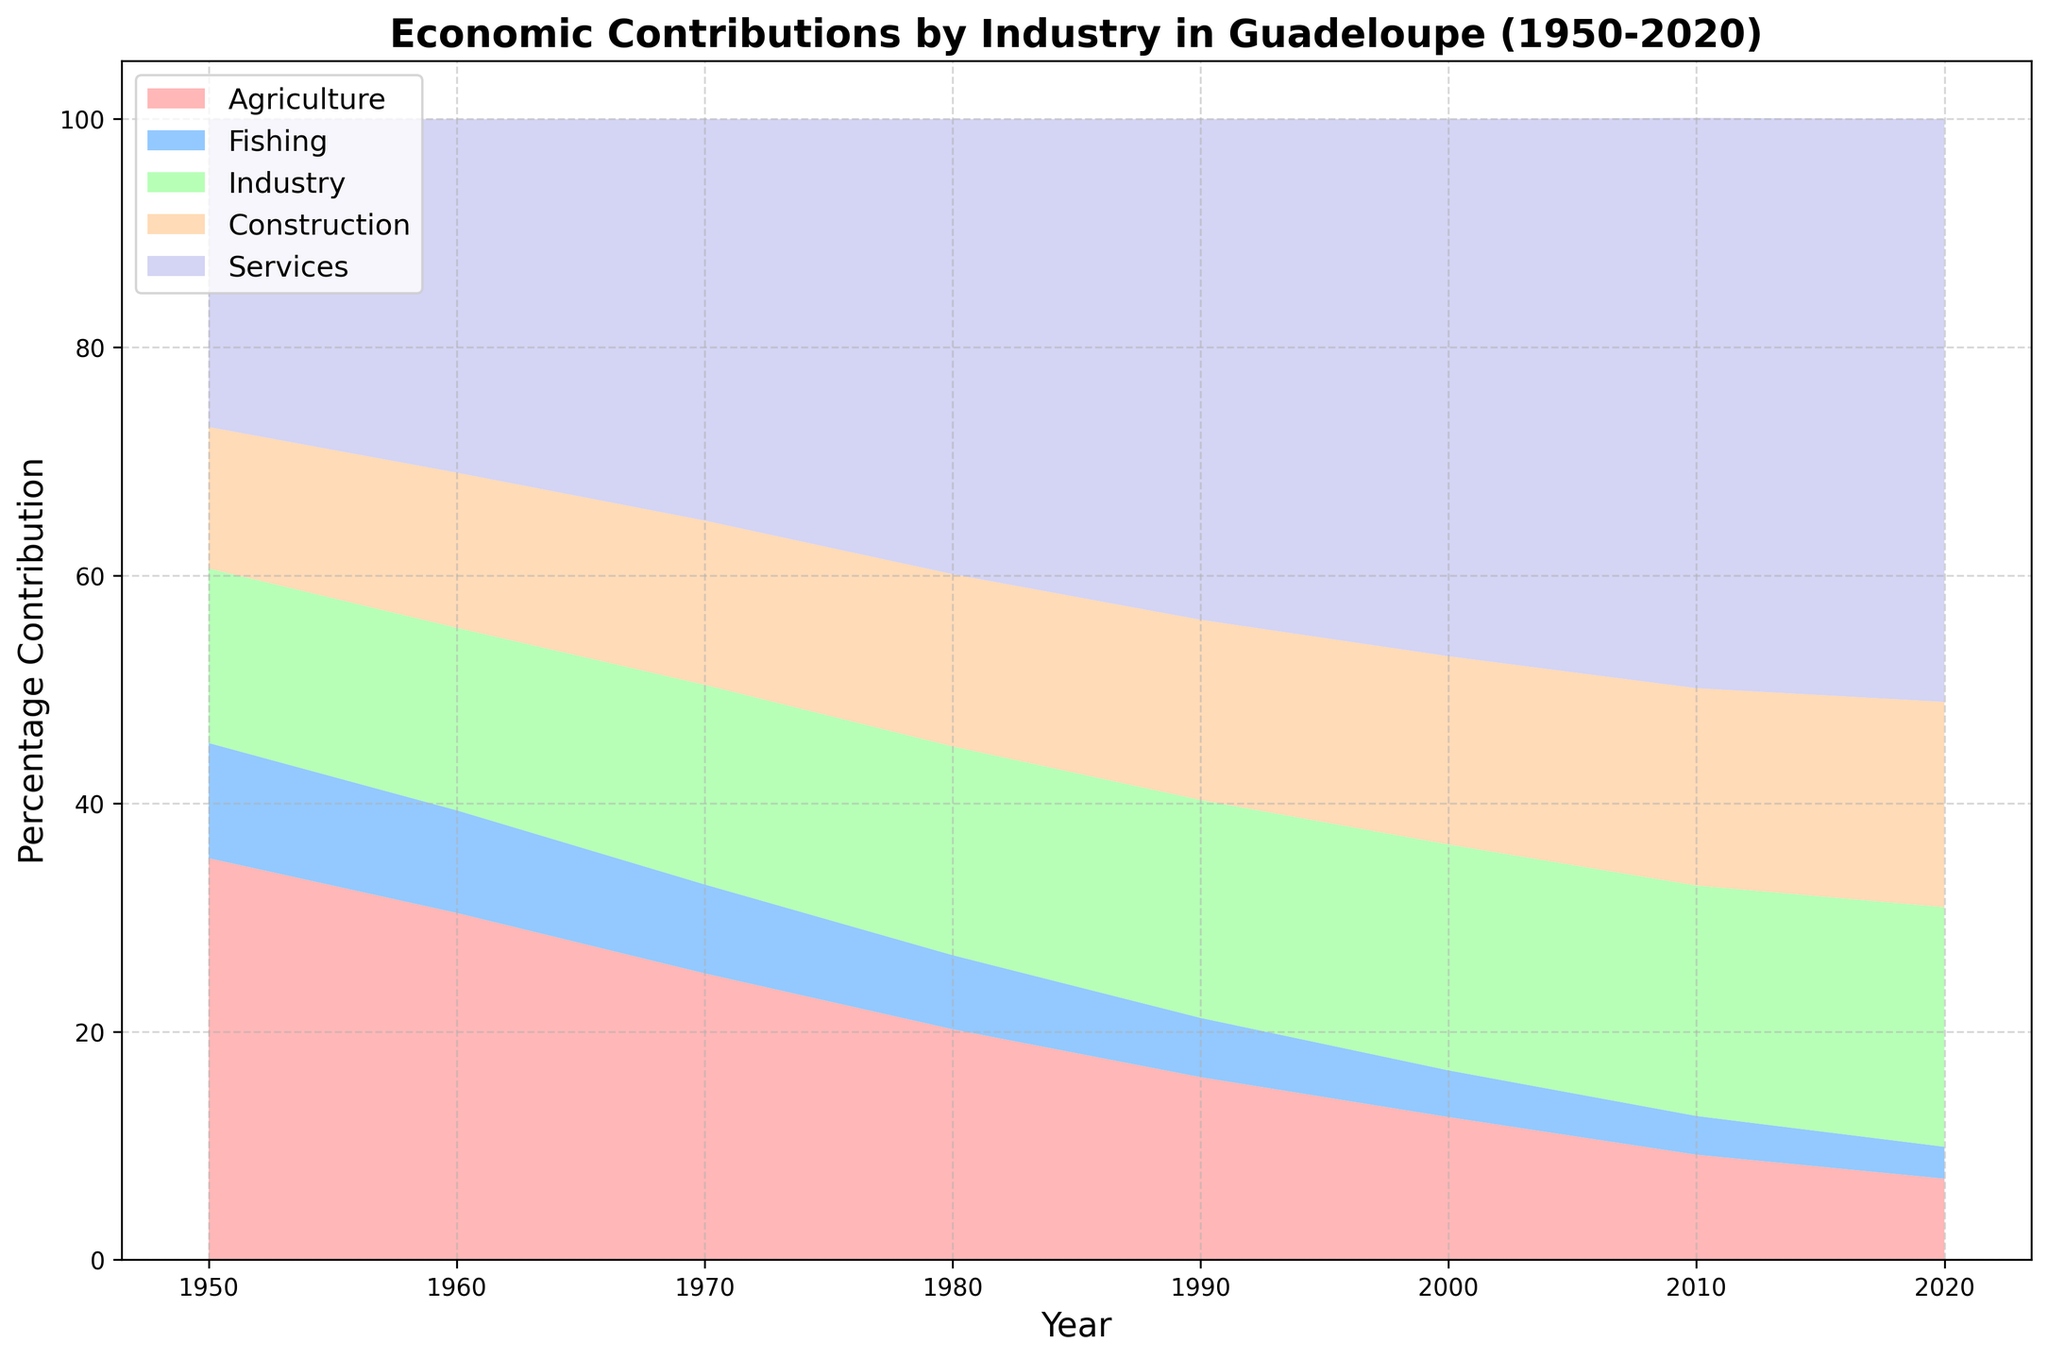Which industry had the highest percentage contribution in 2020? Examine the stack columns in the figure for the year 2020 and identify the highest segment by looking at the topmost section.
Answer: Services How did the contribution of Agriculture change from 1950 to 2020? Look at the height of the red section at 1950 and 2020 on the figure. Calculate the percentage change ((initial - final) / initial * 100).
Answer: Decreased by 28.1% Which two industries have shown a decline in percentage contribution from 1950 to 2020? Compare the heights of the different colored segments for the years 1950 and 2020, noting which have decreased.
Answer: Agriculture and Fishing What is the combined percentage contribution of Industry and Construction in 1980? Identify the heights of the green (Industry) and orange (Construction) segments in 1980 and sum them up.
Answer: 33.4% Compared to 1950, how much has the Services sector grown by 2000? Compare the heights of the purple section in 1950 and 2000. Calculate the absolute increase in percentage points.
Answer: Increased by 20.1% Which decade shows the most significant decline in Agriculture's contribution? Examine the height of the red section across the decades to identify the steepest decline.
Answer: 1970s By how much did the Fishing industry's contribution decrease from 1960 to 2020? Compare the heights of the blue section in 1960 and 2020, calculate the difference.
Answer: Decreased by 6.2% What is the overall trend of the Construction industry's contribution over the years? Observe the height of the orange section from 1950 to 2020.
Answer: Increasing trend Which industry had a relatively stable contribution from 1950 to 2020? Identify the segment whose height shows little changes throughout the years.
Answer: Industry By 2020, how much larger is the Services sector compared to the Agriculture sector? Subtract the height of the red section from the height of the purple section in 2020. Calculate the difference.
Answer: 44.0% 